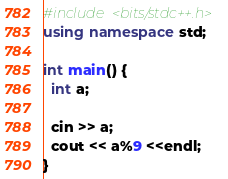<code> <loc_0><loc_0><loc_500><loc_500><_C++_>#include <bits/stdc++.h>
using namespace std;

int main() {
  int a;
  
  cin >> a;
  cout << a%9 <<endl;
}
</code> 